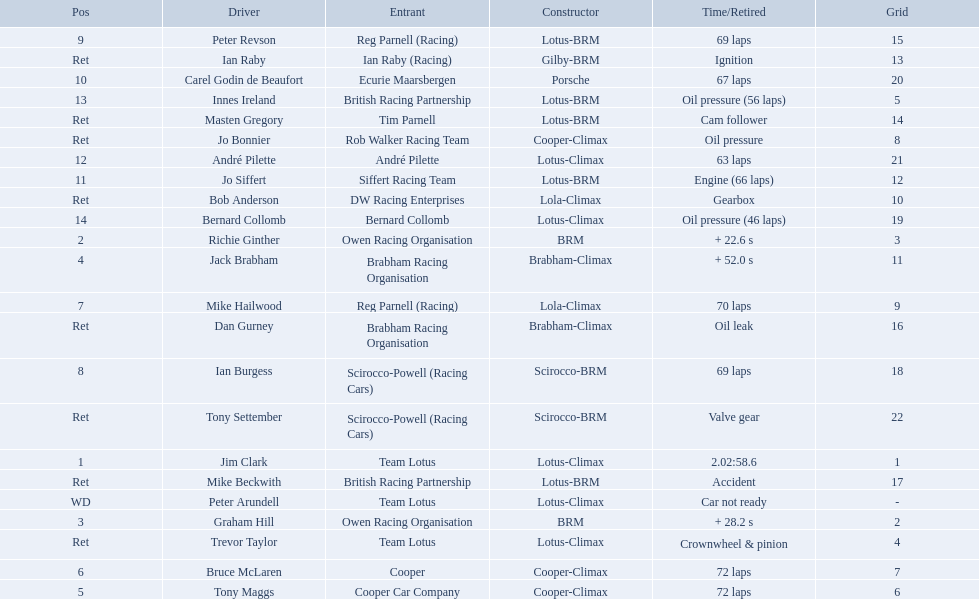Who are all the drivers? Jim Clark, Richie Ginther, Graham Hill, Jack Brabham, Tony Maggs, Bruce McLaren, Mike Hailwood, Ian Burgess, Peter Revson, Carel Godin de Beaufort, Jo Siffert, André Pilette, Innes Ireland, Bernard Collomb, Ian Raby, Dan Gurney, Mike Beckwith, Masten Gregory, Trevor Taylor, Jo Bonnier, Tony Settember, Bob Anderson, Peter Arundell. Which drove a cooper-climax? Tony Maggs, Bruce McLaren, Jo Bonnier. Of those, who was the top finisher? Tony Maggs. Who are all the drivers? Jim Clark, Richie Ginther, Graham Hill, Jack Brabham, Tony Maggs, Bruce McLaren, Mike Hailwood, Ian Burgess, Peter Revson, Carel Godin de Beaufort, Jo Siffert, André Pilette, Innes Ireland, Bernard Collomb, Ian Raby, Dan Gurney, Mike Beckwith, Masten Gregory, Trevor Taylor, Jo Bonnier, Tony Settember, Bob Anderson, Peter Arundell. What position were they in? 1, 2, 3, 4, 5, 6, 7, 8, 9, 10, 11, 12, 13, 14, Ret, Ret, Ret, Ret, Ret, Ret, Ret, Ret, WD. What about just tony maggs and jo siffert? 5, 11. And between them, which driver came in earlier? Tony Maggs. 